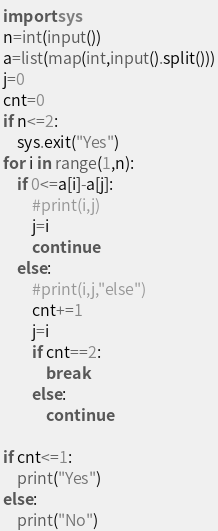<code> <loc_0><loc_0><loc_500><loc_500><_Python_>import sys
n=int(input())
a=list(map(int,input().split()))
j=0
cnt=0
if n<=2:
    sys.exit("Yes")
for i in range(1,n):
    if 0<=a[i]-a[j]:
        #print(i,j)
        j=i
        continue
    else:
        #print(i,j,"else")
        cnt+=1
        j=i
        if cnt==2:
            break
        else:
            continue
        
if cnt<=1:
    print("Yes")
else:
    print("No")
</code> 